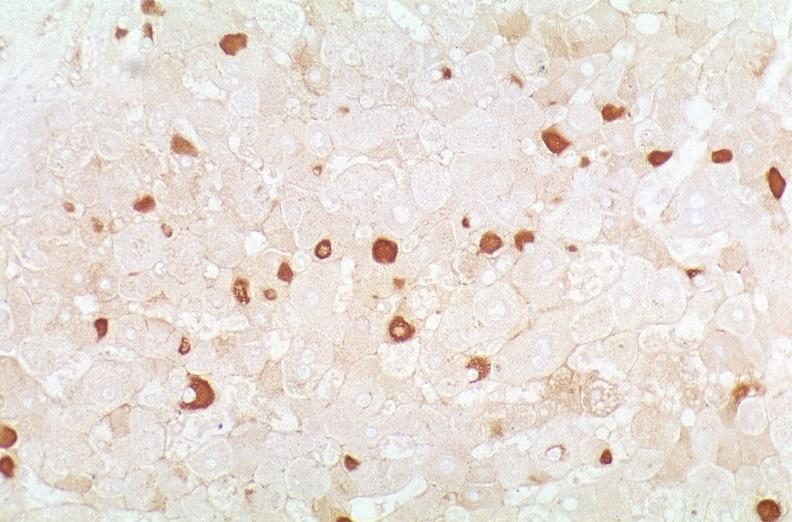s fracture present?
Answer the question using a single word or phrase. No 